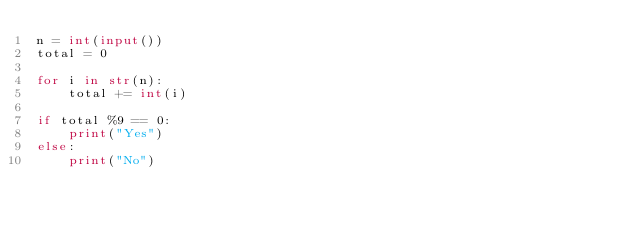<code> <loc_0><loc_0><loc_500><loc_500><_Python_>n = int(input())
total = 0

for i in str(n):
    total += int(i)

if total %9 == 0:
    print("Yes")
else:
    print("No")</code> 